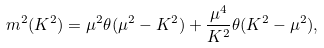Convert formula to latex. <formula><loc_0><loc_0><loc_500><loc_500>m ^ { 2 } ( K ^ { 2 } ) = \mu ^ { 2 } \theta ( \mu ^ { 2 } - K ^ { 2 } ) + \frac { \mu ^ { 4 } } { K ^ { 2 } } \theta ( K ^ { 2 } - \mu ^ { 2 } ) ,</formula> 